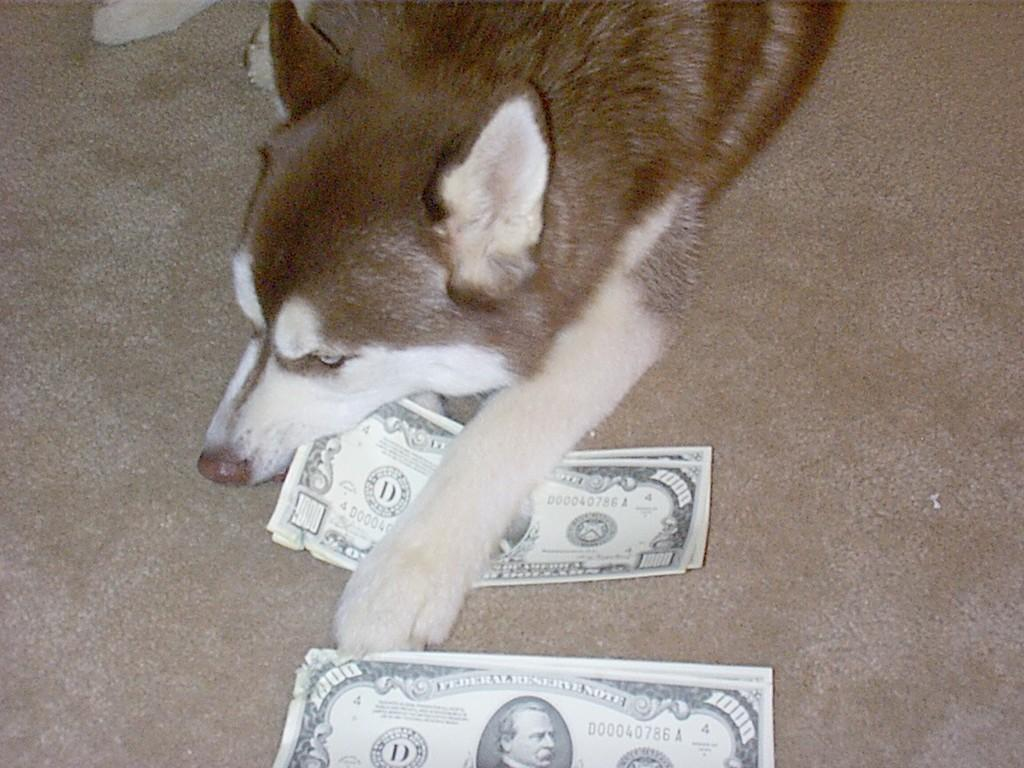What type of animal is in the image? There is a brown dog in the image. What is the dog doing in the image? The dog is lying on dollar notes. What type of fan is visible in the image? There is no fan present in the image. What action is the dog performing in the image? The dog is lying down in the image, not performing any specific action. 